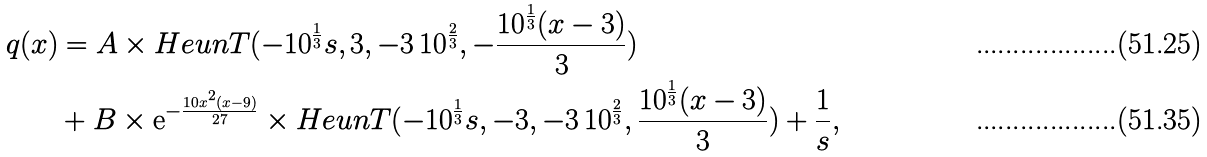Convert formula to latex. <formula><loc_0><loc_0><loc_500><loc_500>q ( x ) & = A \times H e u n T ( - 1 0 ^ { \frac { 1 } { 3 } } s , 3 , - 3 \, 1 0 ^ { \frac { 2 } { 3 } } , - \frac { 1 0 ^ { \frac { 1 } { 3 } } ( x - 3 ) } { 3 } ) \\ & + B \times { \mathrm e } ^ { - \frac { 1 0 x ^ { 2 } ( x - 9 ) } { 2 7 } } \times H e u n T ( - 1 0 ^ { \frac { 1 } { 3 } } s , - 3 , - 3 \, 1 0 ^ { \frac { 2 } { 3 } } , \frac { 1 0 ^ { \frac { 1 } { 3 } } ( x - 3 ) } { 3 } ) + \frac { 1 } { s } ,</formula> 